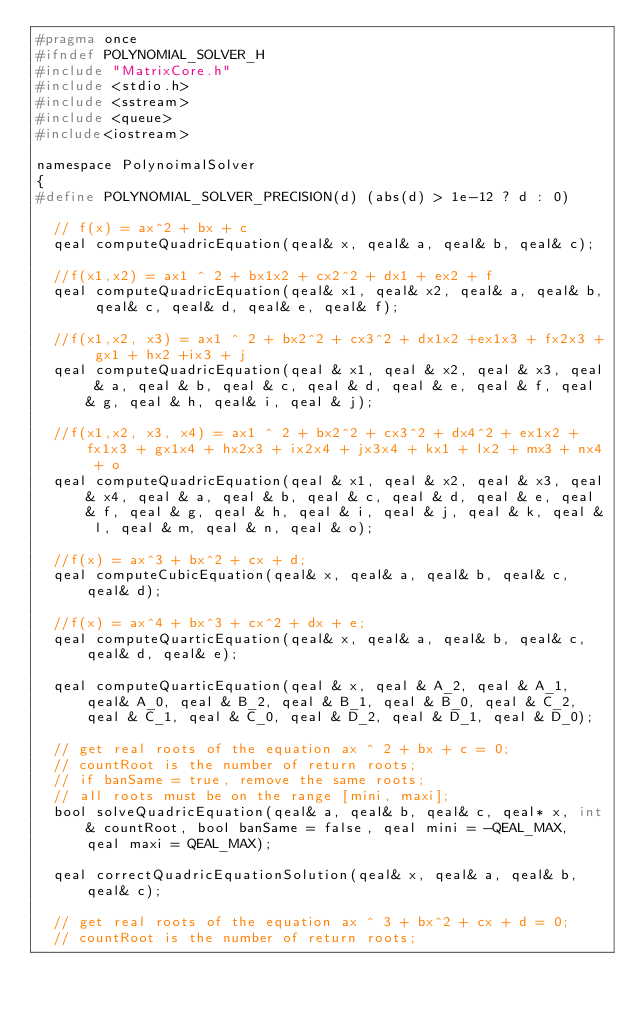<code> <loc_0><loc_0><loc_500><loc_500><_C_>#pragma once
#ifndef POLYNOMIAL_SOLVER_H
#include "MatrixCore.h"
#include <stdio.h>
#include <sstream>
#include <queue>
#include<iostream>

namespace PolynoimalSolver
{
#define POLYNOMIAL_SOLVER_PRECISION(d) (abs(d) > 1e-12 ? d : 0)
	
	// f(x) = ax^2 + bx + c
	qeal computeQuadricEquation(qeal& x, qeal& a, qeal& b, qeal& c);

	//f(x1,x2) = ax1 ^ 2 + bx1x2 + cx2^2 + dx1 + ex2 + f
	qeal computeQuadricEquation(qeal& x1, qeal& x2, qeal& a, qeal& b, qeal& c, qeal& d, qeal& e, qeal& f);

	//f(x1,x2, x3) = ax1 ^ 2 + bx2^2 + cx3^2 + dx1x2 +ex1x3 + fx2x3 + gx1 + hx2 +ix3 + j
	qeal computeQuadricEquation(qeal & x1, qeal & x2, qeal & x3, qeal & a, qeal & b, qeal & c, qeal & d, qeal & e, qeal & f, qeal & g, qeal & h, qeal& i, qeal & j);

	//f(x1,x2, x3, x4) = ax1 ^ 2 + bx2^2 + cx3^2 + dx4^2 + ex1x2 + fx1x3 + gx1x4 + hx2x3 + ix2x4 + jx3x4 + kx1 + lx2 + mx3 + nx4 + o
	qeal computeQuadricEquation(qeal & x1, qeal & x2, qeal & x3, qeal& x4, qeal & a, qeal & b, qeal & c, qeal & d, qeal & e, qeal & f, qeal & g, qeal & h, qeal & i, qeal & j, qeal & k, qeal & l, qeal & m, qeal & n, qeal & o);

	//f(x) = ax^3 + bx^2 + cx + d;
	qeal computeCubicEquation(qeal& x, qeal& a, qeal& b, qeal& c, qeal& d);

	//f(x) = ax^4 + bx^3 + cx^2 + dx + e;
	qeal computeQuarticEquation(qeal& x, qeal& a, qeal& b, qeal& c, qeal& d, qeal& e);

	qeal computeQuarticEquation(qeal & x, qeal & A_2, qeal & A_1, qeal& A_0, qeal & B_2, qeal & B_1, qeal & B_0, qeal & C_2, qeal & C_1, qeal & C_0, qeal & D_2, qeal & D_1, qeal & D_0);

	// get real roots of the equation ax ^ 2 + bx + c = 0;
	// countRoot is the number of return roots; 
	// if banSame = true, remove the same roots;
	// all roots must be on the range [mini, maxi];
	bool solveQuadricEquation(qeal& a, qeal& b, qeal& c, qeal* x, int& countRoot, bool banSame = false, qeal mini = -QEAL_MAX, qeal maxi = QEAL_MAX);

	qeal correctQuadricEquationSolution(qeal& x, qeal& a, qeal& b, qeal& c);

	// get real roots of the equation ax ^ 3 + bx^2 + cx + d = 0;
	// countRoot is the number of return roots; </code> 